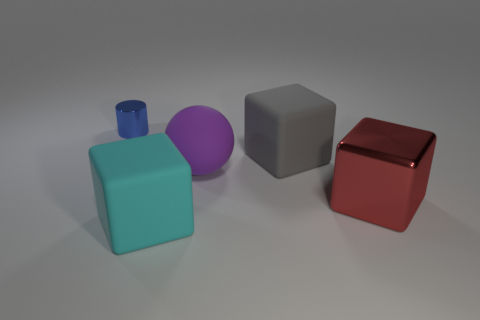Is there any other thing that is the same shape as the cyan object?
Make the answer very short. Yes. There is another big rubber thing that is the same shape as the gray thing; what is its color?
Offer a terse response. Cyan. The gray matte block is what size?
Provide a short and direct response. Large. Are there fewer red things left of the big purple rubber sphere than brown things?
Give a very brief answer. No. Is the cylinder made of the same material as the big cyan thing that is in front of the big gray cube?
Offer a very short reply. No. There is a thing that is behind the cube behind the large red cube; are there any small blue metallic cylinders behind it?
Your answer should be compact. No. Is there any other thing that is the same size as the cyan cube?
Your answer should be very brief. Yes. The other big cube that is the same material as the large gray cube is what color?
Your answer should be very brief. Cyan. What is the size of the thing that is in front of the purple matte ball and right of the big cyan object?
Offer a terse response. Large. Is the number of objects behind the large purple matte thing less than the number of cyan rubber blocks right of the big shiny block?
Offer a very short reply. No. 